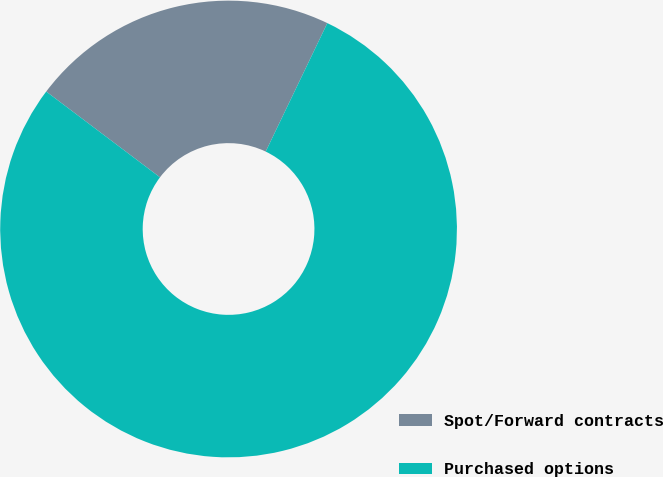<chart> <loc_0><loc_0><loc_500><loc_500><pie_chart><fcel>Spot/Forward contracts<fcel>Purchased options<nl><fcel>21.84%<fcel>78.16%<nl></chart> 